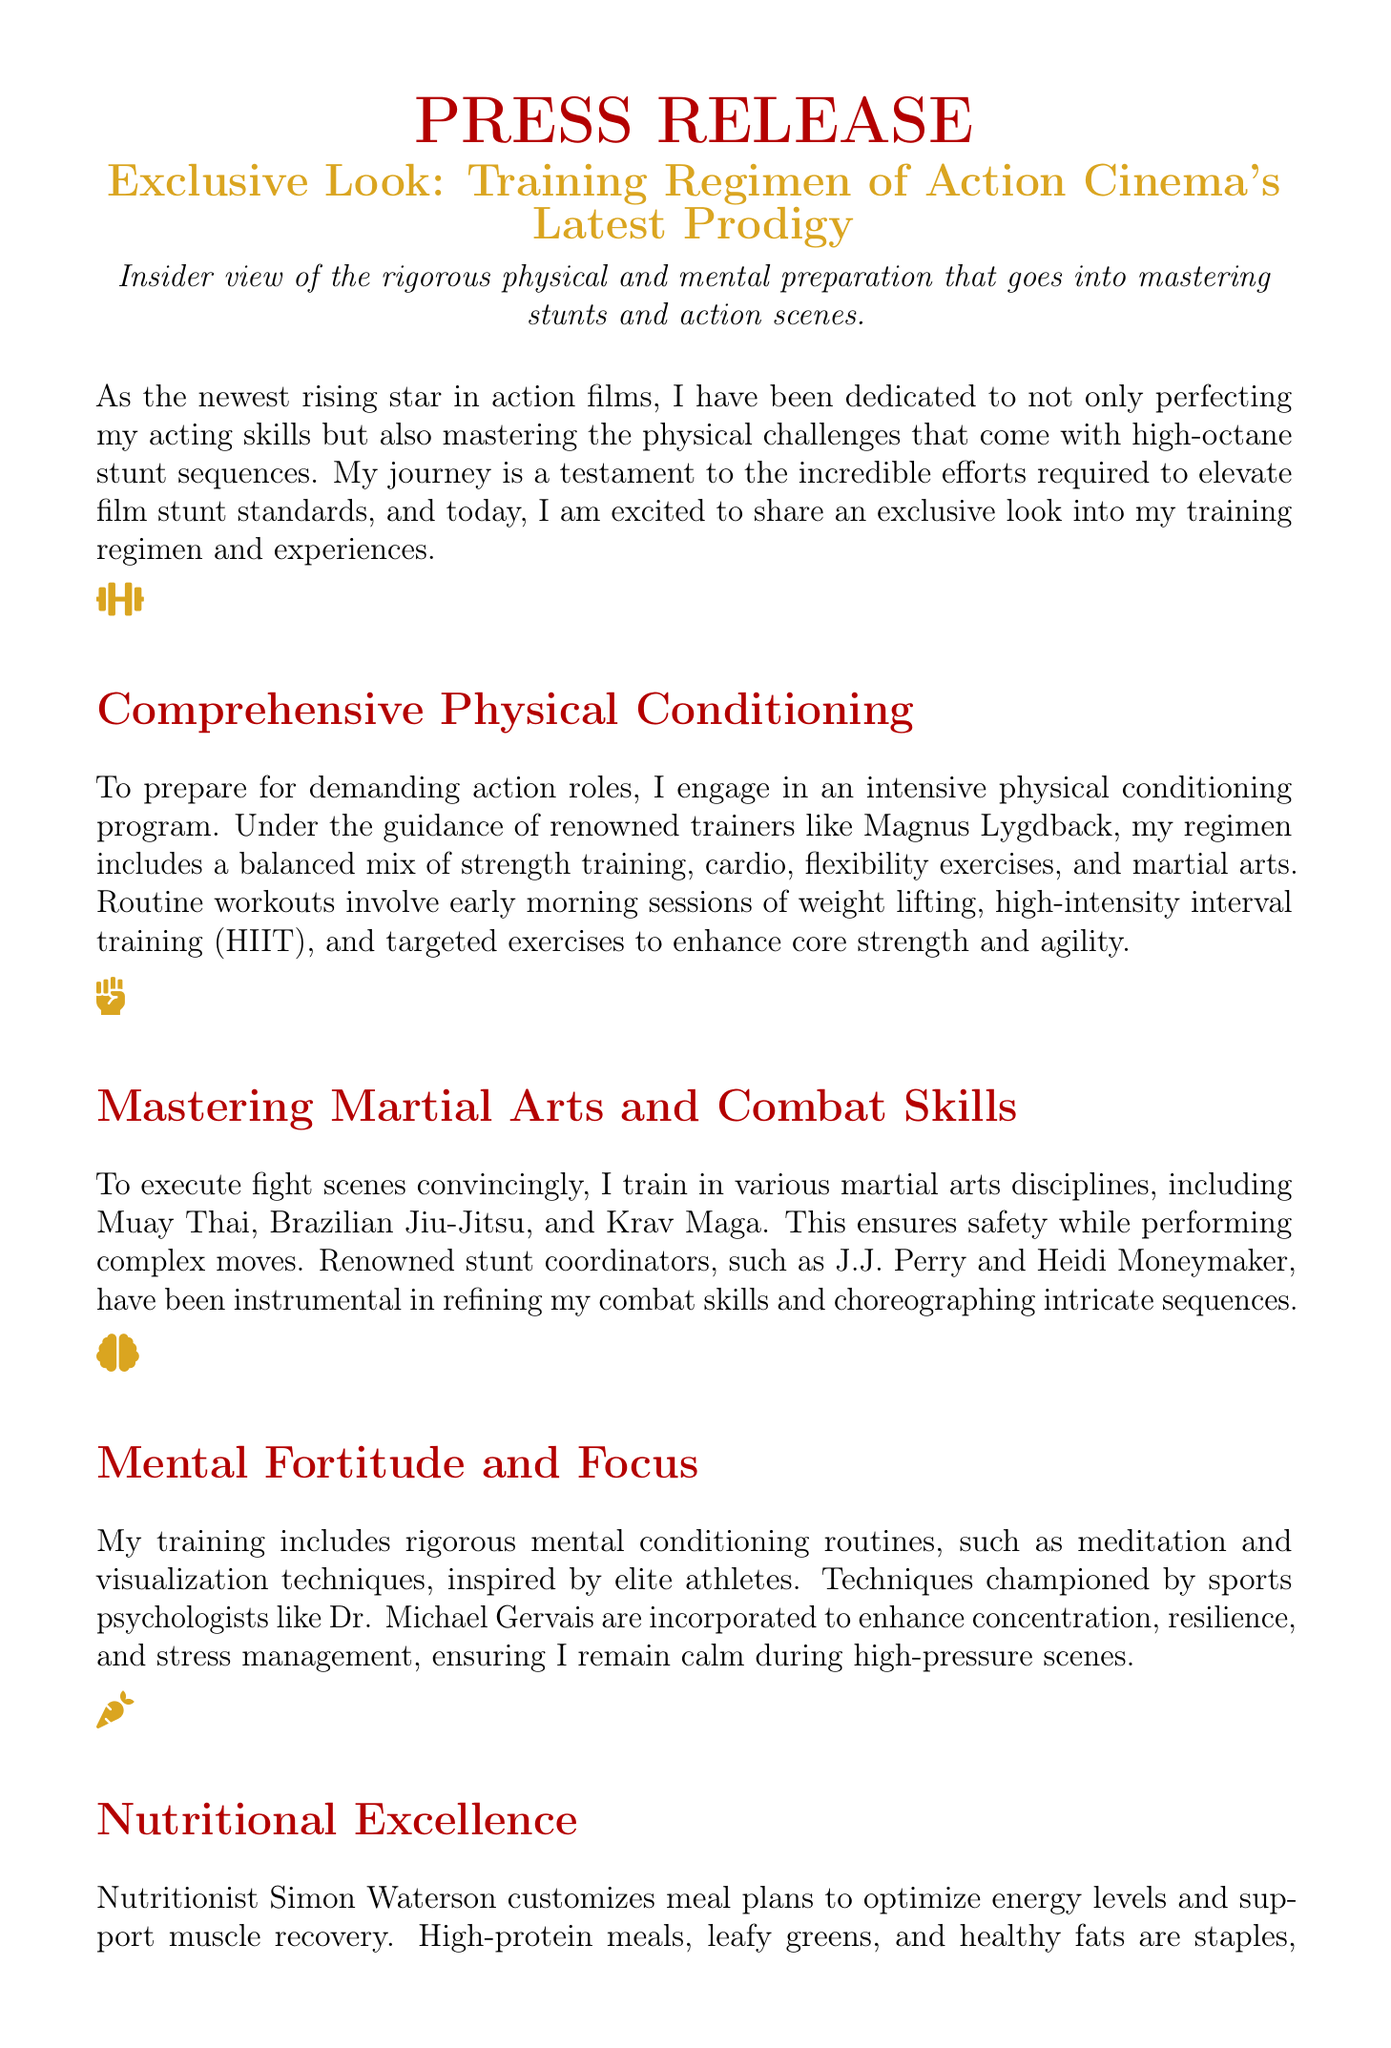What is the name of the renowned trainer mentioned? The document mentions Magnus Lygdback as the renowned trainer guiding the training regimen.
Answer: Magnus Lygdback Which martial arts disciplines are included in the training? The document lists Muay Thai, Brazilian Jiu-Jitsu, and Krav Maga as the martial arts disciplines included in the training.
Answer: Muay Thai, Brazilian Jiu-Jitsu, Krav Maga Who customizes the meal plans for nutrition? The document states that nutritionist Simon Waterson customizes meal plans to optimize energy levels.
Answer: Simon Waterson What type of training is emphasized for high-pressure scenes? The document emphasizes rigorous mental conditioning routines, such as meditation and visualization techniques, for high-pressure scenes.
Answer: Mental conditioning Name two actors mentioned in the collaborative training section. The document mentions Florence Pugh and Amandla Stenberg as actors with whom collaborations took place.
Answer: Florence Pugh, Amandla Stenberg What is the overall goal of the training regimen described? The document states that the overall goal is to set new benchmarks in action cinema and inspire the next generation of actors.
Answer: Set new benchmarks in action cinema How does the training approach contribute to performance in stunt sequences? The document describes that the holistic approach, which includes physical conditioning and mental focus, contributes significantly to performance in stunt sequences.
Answer: Holistic approach What type of scenes are mentioned regarding the performance and training? The document refers to high-octane stunt sequences and fight scenes in the context of performance and training.
Answer: High-octane stunt sequences, fight scenes 